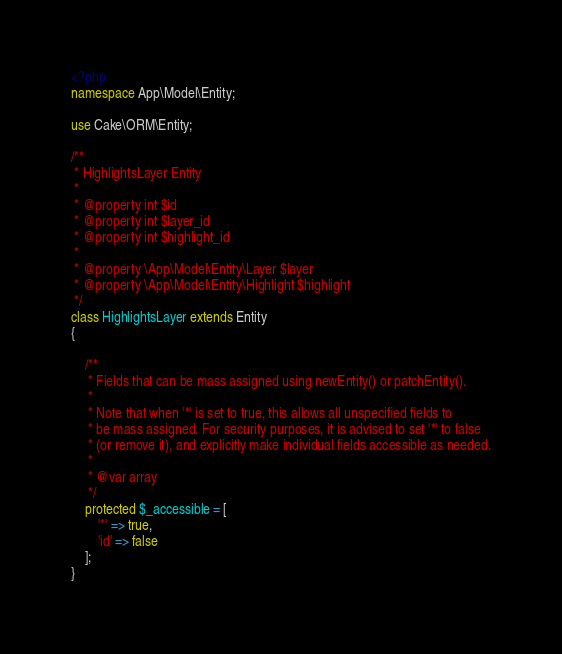<code> <loc_0><loc_0><loc_500><loc_500><_PHP_><?php
namespace App\Model\Entity;

use Cake\ORM\Entity;

/**
 * HighlightsLayer Entity
 *
 * @property int $id
 * @property int $layer_id
 * @property int $highlight_id
 *
 * @property \App\Model\Entity\Layer $layer
 * @property \App\Model\Entity\Highlight $highlight
 */
class HighlightsLayer extends Entity
{

    /**
     * Fields that can be mass assigned using newEntity() or patchEntity().
     *
     * Note that when '*' is set to true, this allows all unspecified fields to
     * be mass assigned. For security purposes, it is advised to set '*' to false
     * (or remove it), and explicitly make individual fields accessible as needed.
     *
     * @var array
     */
    protected $_accessible = [
        '*' => true,
        'id' => false
    ];
}
</code> 